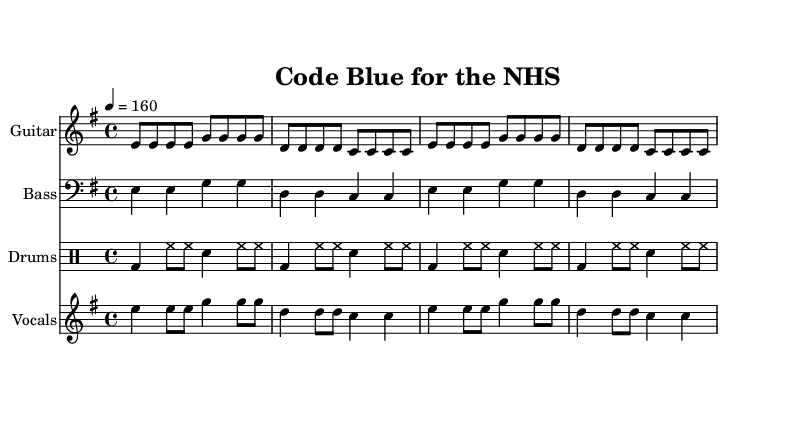What is the key signature of this music? The key signature is E minor, which is indicated by the presence of one sharp (F#) in the musical notation.
Answer: E minor What is the time signature of this music? The time signature is 4/4, which can be identified by the presence of four beats per measure, as shown in the music sheet.
Answer: 4/4 What is the tempo marking of this piece? The tempo marking is 160 beats per minute, which is indicated by the text "4 = 160" near the tempo indication.
Answer: 160 How many measures are in the guitar part? There are 4 measures in the guitar part, identified by counting the slashes in the provided notation for guitar notes.
Answer: 4 What is the main lyrical theme of the song? The main lyrical theme is the crisis of the NHS due to government cuts, as demonstrated by the lyrics "They're cutting our lifeline, we're coding blue".
Answer: NHS crisis What instruments are used in this score? The instruments used in this score are Guitar, Bass, Drums, and Vocals, which are listed at the beginning of their respective staves in the sheet music.
Answer: Guitar, Bass, Drums, Vocals What type of drum pattern is indicated in the drum part? The drum part indicates a basic rock pattern commonly used in punk music, featuring kick (bd), hi-hat (hh), and snare (sn) in a repetitive structure.
Answer: Basic rock pattern 